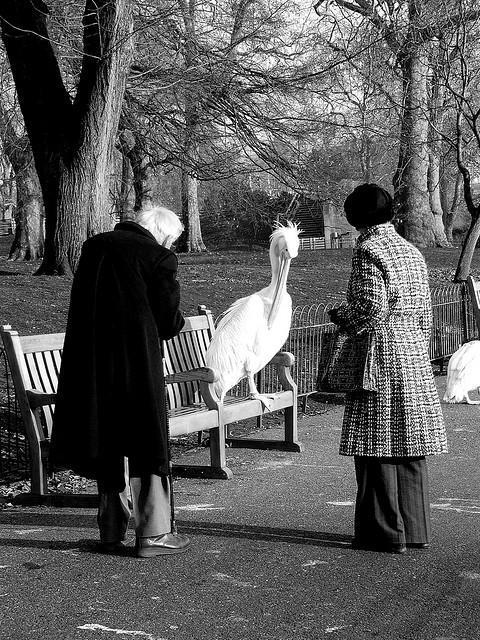What is the bird on the bench called?

Choices:
A) hawk
B) flamingo
C) penguin
D) stork stork 